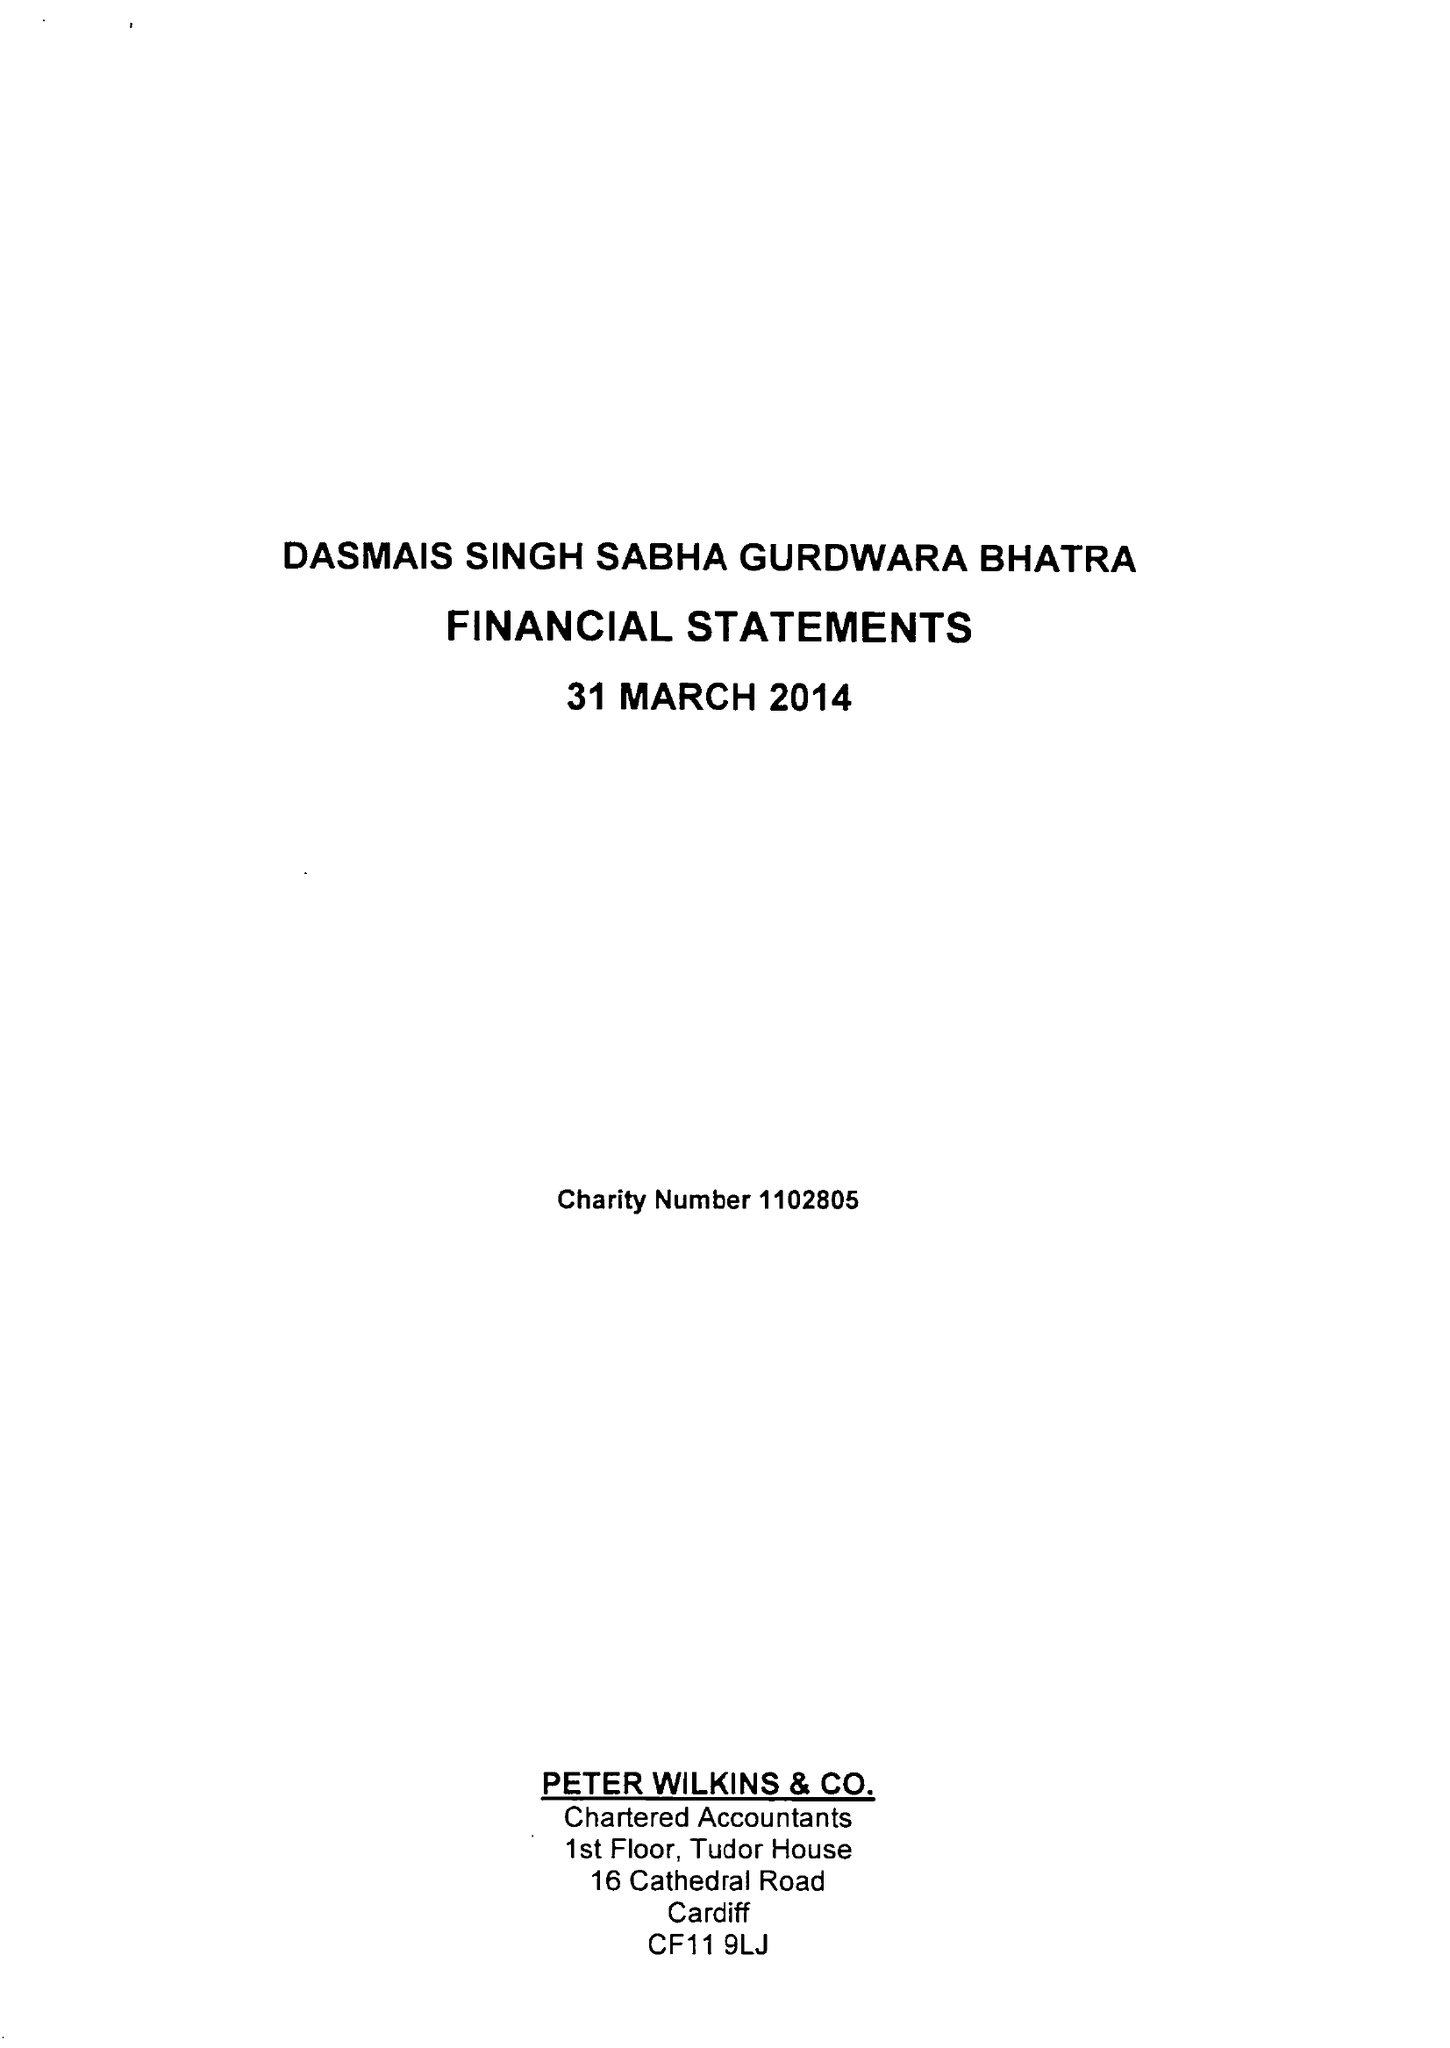What is the value for the report_date?
Answer the question using a single word or phrase. 2014-03-31 